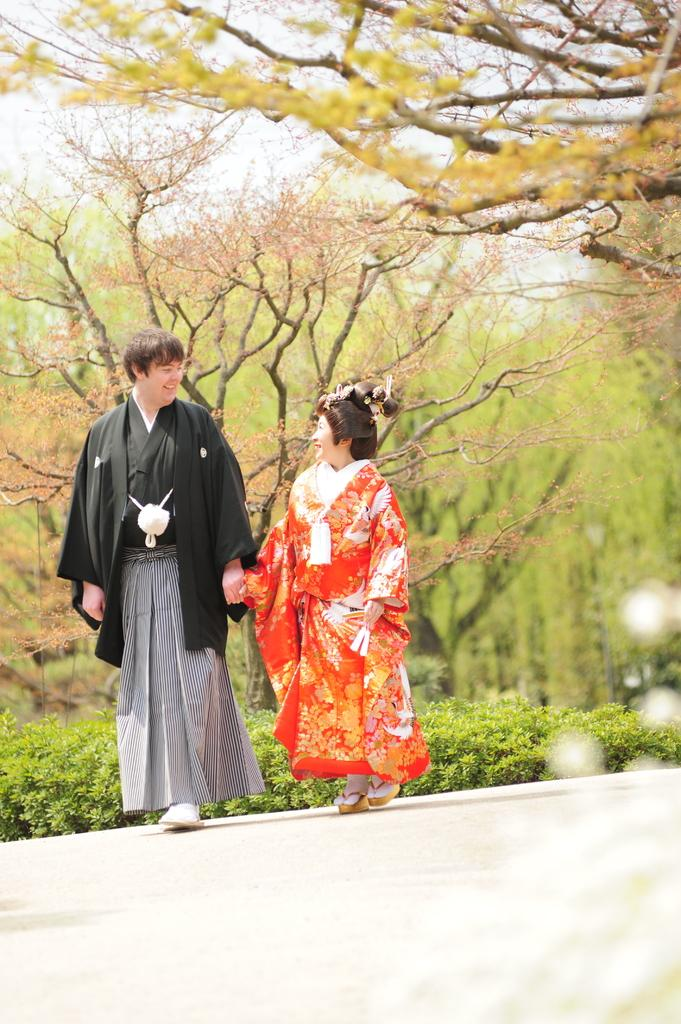How many people are present in the image? There are two people in the image. What is the position of the people in the image? The people are on the ground. What can be seen in the background of the image? There are plants, trees, and the sky visible in the background of the image. What type of card is being discussed by the committee in the image? There is no committee or card present in the image. What kind of waste is visible in the image? There is no waste visible in the image. 